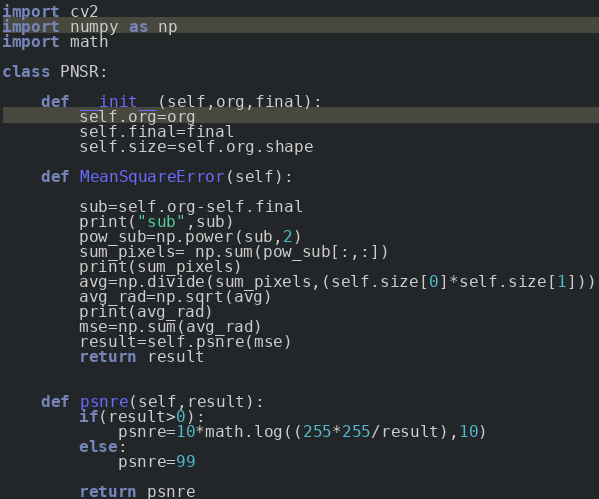Convert code to text. <code><loc_0><loc_0><loc_500><loc_500><_Python_>import cv2
import numpy as np
import math

class PNSR:

    def __init__(self,org,final):
        self.org=org
        self.final=final
        self.size=self.org.shape

    def MeanSquareError(self):

        sub=self.org-self.final
        print("sub",sub)
        pow_sub=np.power(sub,2)
        sum_pixels= np.sum(pow_sub[:,:])
        print(sum_pixels)
        avg=np.divide(sum_pixels,(self.size[0]*self.size[1]))
        avg_rad=np.sqrt(avg)
        print(avg_rad)
        mse=np.sum(avg_rad)
        result=self.psnre(mse)
        return result


    def psnre(self,result):
        if(result>0):
            psnre=10*math.log((255*255/result),10)
        else:
            psnre=99

        return psnre
</code> 